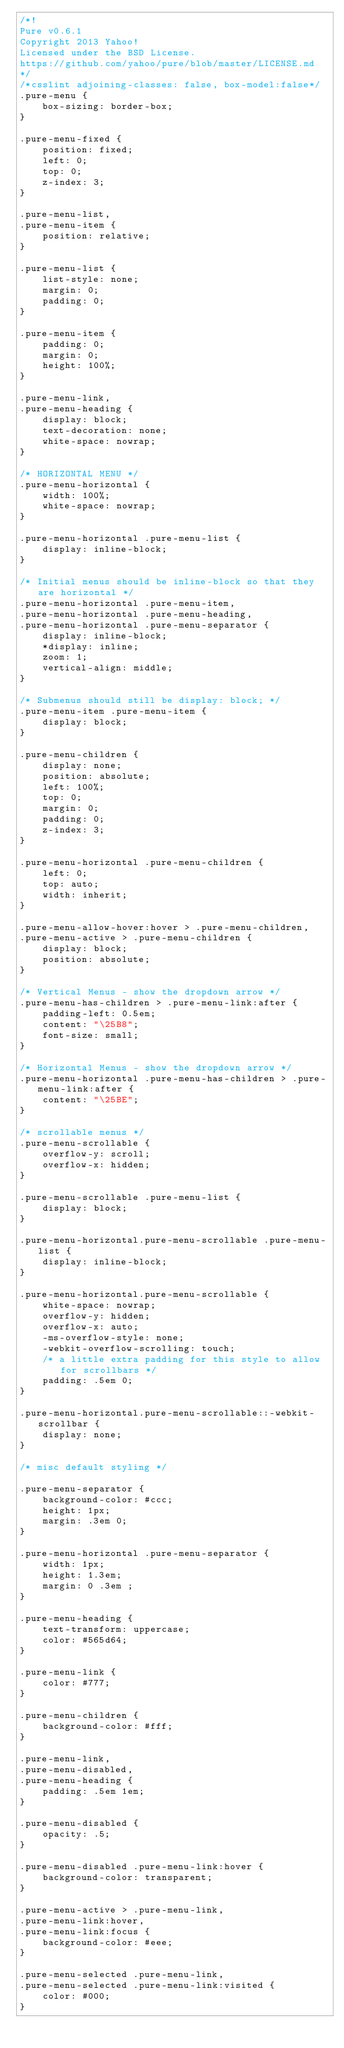<code> <loc_0><loc_0><loc_500><loc_500><_CSS_>/*!
Pure v0.6.1
Copyright 2013 Yahoo!
Licensed under the BSD License.
https://github.com/yahoo/pure/blob/master/LICENSE.md
*/
/*csslint adjoining-classes: false, box-model:false*/
.pure-menu {
    box-sizing: border-box;
}

.pure-menu-fixed {
    position: fixed;
    left: 0;
    top: 0;
    z-index: 3;
}

.pure-menu-list,
.pure-menu-item {
    position: relative;
}

.pure-menu-list {
    list-style: none;
    margin: 0;
    padding: 0;
}

.pure-menu-item {
    padding: 0;
    margin: 0;
    height: 100%;
}

.pure-menu-link,
.pure-menu-heading {
    display: block;
    text-decoration: none;
    white-space: nowrap;
}

/* HORIZONTAL MENU */
.pure-menu-horizontal {
    width: 100%;
    white-space: nowrap;
}

.pure-menu-horizontal .pure-menu-list {
    display: inline-block;
}

/* Initial menus should be inline-block so that they are horizontal */
.pure-menu-horizontal .pure-menu-item,
.pure-menu-horizontal .pure-menu-heading,
.pure-menu-horizontal .pure-menu-separator {
    display: inline-block;
    *display: inline;
    zoom: 1;
    vertical-align: middle;
}

/* Submenus should still be display: block; */
.pure-menu-item .pure-menu-item {
    display: block;
}

.pure-menu-children {
    display: none;
    position: absolute;
    left: 100%;
    top: 0;
    margin: 0;
    padding: 0;
    z-index: 3;
}

.pure-menu-horizontal .pure-menu-children {
    left: 0;
    top: auto;
    width: inherit;
}

.pure-menu-allow-hover:hover > .pure-menu-children,
.pure-menu-active > .pure-menu-children {
    display: block;
    position: absolute;
}

/* Vertical Menus - show the dropdown arrow */
.pure-menu-has-children > .pure-menu-link:after {
    padding-left: 0.5em;
    content: "\25B8";
    font-size: small;
}

/* Horizontal Menus - show the dropdown arrow */
.pure-menu-horizontal .pure-menu-has-children > .pure-menu-link:after {
    content: "\25BE";
}

/* scrollable menus */
.pure-menu-scrollable {
    overflow-y: scroll;
    overflow-x: hidden;
}

.pure-menu-scrollable .pure-menu-list {
    display: block;
}

.pure-menu-horizontal.pure-menu-scrollable .pure-menu-list {
    display: inline-block;
}

.pure-menu-horizontal.pure-menu-scrollable {
    white-space: nowrap;
    overflow-y: hidden;
    overflow-x: auto;
    -ms-overflow-style: none;
    -webkit-overflow-scrolling: touch;
    /* a little extra padding for this style to allow for scrollbars */
    padding: .5em 0;
}

.pure-menu-horizontal.pure-menu-scrollable::-webkit-scrollbar {
    display: none;
}

/* misc default styling */

.pure-menu-separator {
    background-color: #ccc;
    height: 1px;
    margin: .3em 0;
}

.pure-menu-horizontal .pure-menu-separator {
    width: 1px;
    height: 1.3em;
    margin: 0 .3em ;
}

.pure-menu-heading {
    text-transform: uppercase;
    color: #565d64;
}

.pure-menu-link {
    color: #777;
}

.pure-menu-children {
    background-color: #fff;
}

.pure-menu-link,
.pure-menu-disabled,
.pure-menu-heading {
    padding: .5em 1em;
}

.pure-menu-disabled {
    opacity: .5;
}

.pure-menu-disabled .pure-menu-link:hover {
    background-color: transparent;
}

.pure-menu-active > .pure-menu-link,
.pure-menu-link:hover,
.pure-menu-link:focus {
    background-color: #eee;
}

.pure-menu-selected .pure-menu-link,
.pure-menu-selected .pure-menu-link:visited {
    color: #000;
}
</code> 